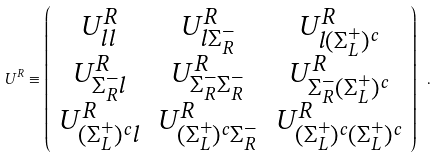Convert formula to latex. <formula><loc_0><loc_0><loc_500><loc_500>U ^ { R } \equiv \left ( \begin{array} { c c c } U ^ { R } _ { l l } & U ^ { R } _ { l \Sigma _ { R } ^ { - } } & U ^ { R } _ { l ( \Sigma _ { L } ^ { + } ) ^ { c } } \\ U ^ { R } _ { \Sigma _ { R } ^ { - } l } & U ^ { R } _ { \Sigma _ { R } ^ { - } \Sigma _ { R } ^ { - } } & U ^ { R } _ { \Sigma _ { R } ^ { - } ( \Sigma _ { L } ^ { + } ) ^ { c } } \\ U ^ { R } _ { ( \Sigma _ { L } ^ { + } ) ^ { c } l } & U ^ { R } _ { ( \Sigma _ { L } ^ { + } ) ^ { c } \Sigma _ { R } ^ { - } } & U ^ { R } _ { ( \Sigma _ { L } ^ { + } ) ^ { c } ( \Sigma _ { L } ^ { + } ) ^ { c } } \\ \end{array} \right ) \ .</formula> 